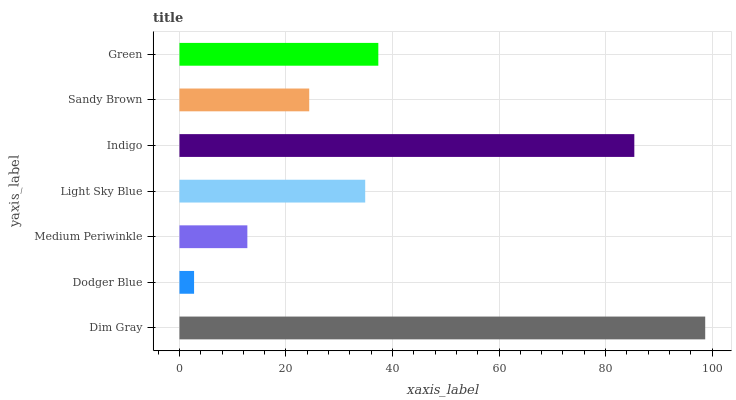Is Dodger Blue the minimum?
Answer yes or no. Yes. Is Dim Gray the maximum?
Answer yes or no. Yes. Is Medium Periwinkle the minimum?
Answer yes or no. No. Is Medium Periwinkle the maximum?
Answer yes or no. No. Is Medium Periwinkle greater than Dodger Blue?
Answer yes or no. Yes. Is Dodger Blue less than Medium Periwinkle?
Answer yes or no. Yes. Is Dodger Blue greater than Medium Periwinkle?
Answer yes or no. No. Is Medium Periwinkle less than Dodger Blue?
Answer yes or no. No. Is Light Sky Blue the high median?
Answer yes or no. Yes. Is Light Sky Blue the low median?
Answer yes or no. Yes. Is Sandy Brown the high median?
Answer yes or no. No. Is Green the low median?
Answer yes or no. No. 